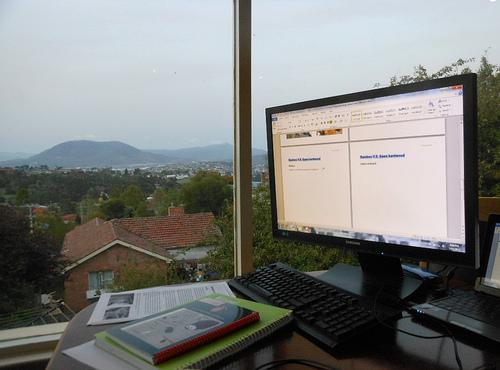Question: what is in the distance?
Choices:
A. An ocean.
B. The cloud.
C. A beachhouse.
D. A mountain.
Answer with the letter. Answer: D Question: when was this taken?
Choices:
A. At night.
B. Midday.
C. At noon.
D. In the morning.
Answer with the letter. Answer: B 